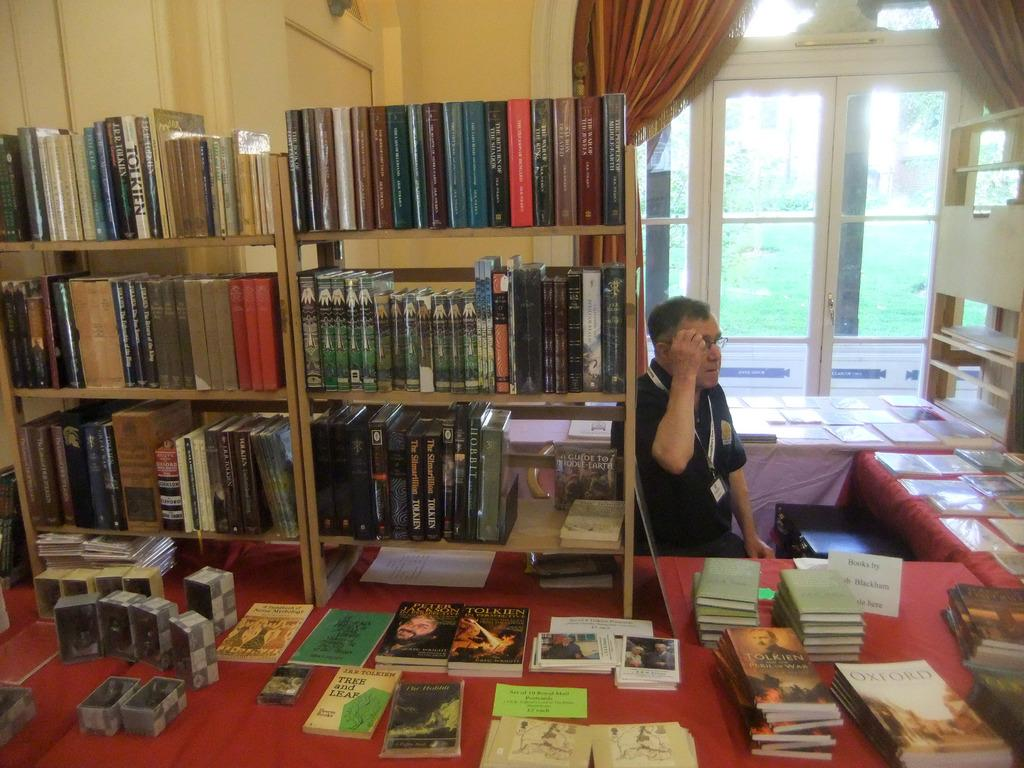Provide a one-sentence caption for the provided image. Several books on the table with sign, "books by Blackham". 